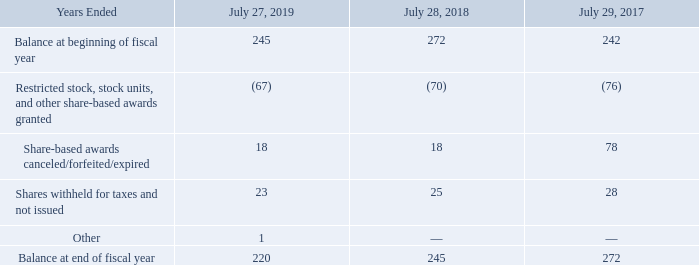(d) Share-Based Awards Available for Grant
A summary of share-based awards available for grant is as follows (in millions):
For each share awarded as restricted stock or a restricted stock unit award under the 2005 Plan, 1.5 shares was deducted from the available share-based award balance. For restricted stock units that were awarded with vesting contingent upon the achievement of future financial performance or market-based metrics, the maximum awards that can be achieved upon full vesting of such awards were reflected in the preceding table.
What are the units used in the table? Millions. What was the amount of Other share-based awards in 2019?
Answer scale should be: million. 1. What was the amount of Shares withheld for taxes and not issued in 2017?
Answer scale should be: million. 28. What was the change in Balance at beginning of fiscal year between 2017 and 2018?
Answer scale should be: million. 272-242
Answer: 30. How many years did Shares withheld for taxes and not issued exceed $20 million? 2019##2018##2017
Answer: 3. What was the percentage change in the balance at end of fiscal year between 2018 and 2019?
Answer scale should be: percent. (220-245)/245
Answer: -10.2. 